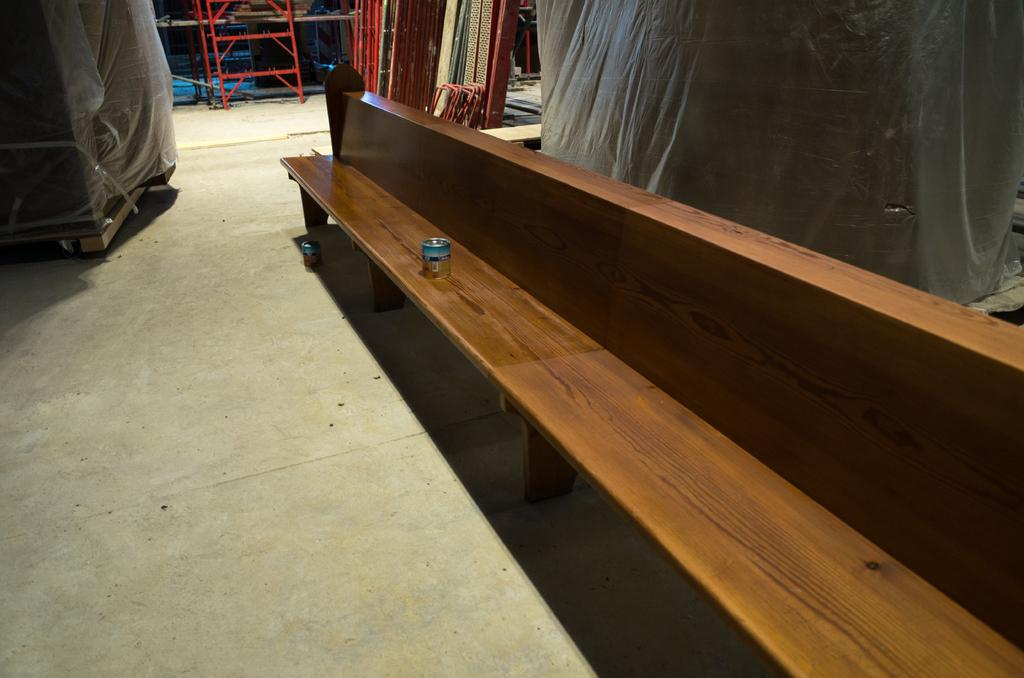What type of furniture is located on the right side of the image? There is a wooden bench on the right side of the image. How many planes are parked on the wooden bench in the image? There are no planes present in the image, as it only features a wooden bench. 